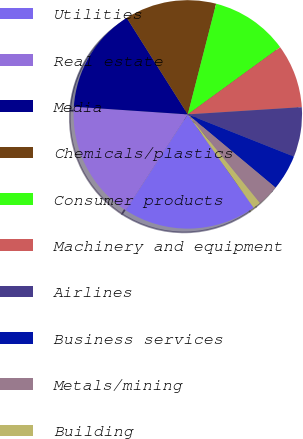Convert chart. <chart><loc_0><loc_0><loc_500><loc_500><pie_chart><fcel>Utilities<fcel>Real estate<fcel>Media<fcel>Chemicals/plastics<fcel>Consumer products<fcel>Machinery and equipment<fcel>Airlines<fcel>Business services<fcel>Metals/mining<fcel>Building<nl><fcel>18.92%<fcel>16.93%<fcel>14.95%<fcel>12.97%<fcel>10.99%<fcel>9.01%<fcel>7.03%<fcel>5.05%<fcel>3.07%<fcel>1.08%<nl></chart> 